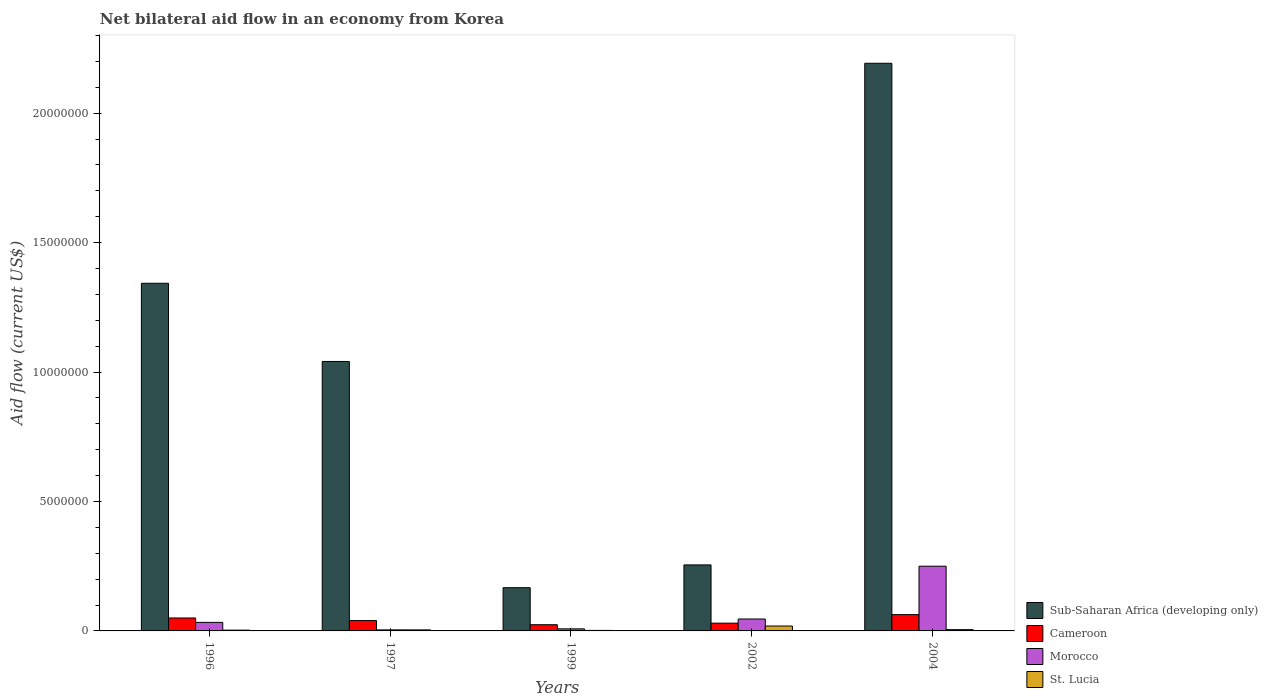How many different coloured bars are there?
Your answer should be compact. 4. How many groups of bars are there?
Provide a short and direct response. 5. Are the number of bars on each tick of the X-axis equal?
Provide a short and direct response. Yes. What is the net bilateral aid flow in Sub-Saharan Africa (developing only) in 1999?
Make the answer very short. 1.67e+06. Across all years, what is the maximum net bilateral aid flow in Cameroon?
Offer a terse response. 6.30e+05. Across all years, what is the minimum net bilateral aid flow in Sub-Saharan Africa (developing only)?
Make the answer very short. 1.67e+06. What is the total net bilateral aid flow in St. Lucia in the graph?
Your response must be concise. 3.30e+05. What is the difference between the net bilateral aid flow in Cameroon in 1999 and that in 2004?
Ensure brevity in your answer.  -3.90e+05. What is the difference between the net bilateral aid flow in St. Lucia in 1996 and the net bilateral aid flow in Cameroon in 2004?
Keep it short and to the point. -6.00e+05. What is the average net bilateral aid flow in Morocco per year?
Provide a succinct answer. 6.82e+05. In the year 1997, what is the difference between the net bilateral aid flow in Morocco and net bilateral aid flow in Sub-Saharan Africa (developing only)?
Give a very brief answer. -1.04e+07. In how many years, is the net bilateral aid flow in Sub-Saharan Africa (developing only) greater than 20000000 US$?
Provide a short and direct response. 1. What is the ratio of the net bilateral aid flow in Sub-Saharan Africa (developing only) in 2002 to that in 2004?
Make the answer very short. 0.12. Is the net bilateral aid flow in St. Lucia in 1999 less than that in 2004?
Provide a succinct answer. Yes. What is the difference between the highest and the second highest net bilateral aid flow in Morocco?
Your answer should be compact. 2.04e+06. What is the difference between the highest and the lowest net bilateral aid flow in Morocco?
Offer a terse response. 2.46e+06. Is the sum of the net bilateral aid flow in St. Lucia in 1997 and 1999 greater than the maximum net bilateral aid flow in Cameroon across all years?
Give a very brief answer. No. What does the 2nd bar from the left in 2002 represents?
Offer a terse response. Cameroon. What does the 2nd bar from the right in 1999 represents?
Provide a succinct answer. Morocco. Is it the case that in every year, the sum of the net bilateral aid flow in Morocco and net bilateral aid flow in Sub-Saharan Africa (developing only) is greater than the net bilateral aid flow in Cameroon?
Provide a succinct answer. Yes. How many bars are there?
Your answer should be very brief. 20. Are all the bars in the graph horizontal?
Offer a terse response. No. What is the difference between two consecutive major ticks on the Y-axis?
Offer a very short reply. 5.00e+06. Where does the legend appear in the graph?
Offer a terse response. Bottom right. How are the legend labels stacked?
Ensure brevity in your answer.  Vertical. What is the title of the graph?
Offer a very short reply. Net bilateral aid flow in an economy from Korea. What is the label or title of the Y-axis?
Provide a short and direct response. Aid flow (current US$). What is the Aid flow (current US$) in Sub-Saharan Africa (developing only) in 1996?
Offer a terse response. 1.34e+07. What is the Aid flow (current US$) of Cameroon in 1996?
Provide a short and direct response. 5.00e+05. What is the Aid flow (current US$) in Morocco in 1996?
Your answer should be very brief. 3.30e+05. What is the Aid flow (current US$) in Sub-Saharan Africa (developing only) in 1997?
Provide a short and direct response. 1.04e+07. What is the Aid flow (current US$) of Cameroon in 1997?
Your response must be concise. 4.00e+05. What is the Aid flow (current US$) in Morocco in 1997?
Provide a succinct answer. 4.00e+04. What is the Aid flow (current US$) in Sub-Saharan Africa (developing only) in 1999?
Offer a very short reply. 1.67e+06. What is the Aid flow (current US$) of Cameroon in 1999?
Your answer should be compact. 2.40e+05. What is the Aid flow (current US$) of Morocco in 1999?
Offer a terse response. 8.00e+04. What is the Aid flow (current US$) of Sub-Saharan Africa (developing only) in 2002?
Your answer should be compact. 2.55e+06. What is the Aid flow (current US$) in Cameroon in 2002?
Provide a short and direct response. 3.00e+05. What is the Aid flow (current US$) of Morocco in 2002?
Your response must be concise. 4.60e+05. What is the Aid flow (current US$) in Sub-Saharan Africa (developing only) in 2004?
Offer a terse response. 2.19e+07. What is the Aid flow (current US$) in Cameroon in 2004?
Your response must be concise. 6.30e+05. What is the Aid flow (current US$) of Morocco in 2004?
Keep it short and to the point. 2.50e+06. Across all years, what is the maximum Aid flow (current US$) of Sub-Saharan Africa (developing only)?
Give a very brief answer. 2.19e+07. Across all years, what is the maximum Aid flow (current US$) in Cameroon?
Your answer should be compact. 6.30e+05. Across all years, what is the maximum Aid flow (current US$) in Morocco?
Provide a short and direct response. 2.50e+06. Across all years, what is the maximum Aid flow (current US$) in St. Lucia?
Your response must be concise. 1.90e+05. Across all years, what is the minimum Aid flow (current US$) of Sub-Saharan Africa (developing only)?
Offer a very short reply. 1.67e+06. Across all years, what is the minimum Aid flow (current US$) of Cameroon?
Make the answer very short. 2.40e+05. What is the total Aid flow (current US$) of Sub-Saharan Africa (developing only) in the graph?
Give a very brief answer. 5.00e+07. What is the total Aid flow (current US$) in Cameroon in the graph?
Ensure brevity in your answer.  2.07e+06. What is the total Aid flow (current US$) of Morocco in the graph?
Offer a very short reply. 3.41e+06. What is the total Aid flow (current US$) in St. Lucia in the graph?
Offer a very short reply. 3.30e+05. What is the difference between the Aid flow (current US$) of Sub-Saharan Africa (developing only) in 1996 and that in 1997?
Provide a short and direct response. 3.02e+06. What is the difference between the Aid flow (current US$) in Sub-Saharan Africa (developing only) in 1996 and that in 1999?
Provide a short and direct response. 1.18e+07. What is the difference between the Aid flow (current US$) of Cameroon in 1996 and that in 1999?
Ensure brevity in your answer.  2.60e+05. What is the difference between the Aid flow (current US$) of Sub-Saharan Africa (developing only) in 1996 and that in 2002?
Keep it short and to the point. 1.09e+07. What is the difference between the Aid flow (current US$) in St. Lucia in 1996 and that in 2002?
Give a very brief answer. -1.60e+05. What is the difference between the Aid flow (current US$) in Sub-Saharan Africa (developing only) in 1996 and that in 2004?
Provide a succinct answer. -8.50e+06. What is the difference between the Aid flow (current US$) of Cameroon in 1996 and that in 2004?
Provide a succinct answer. -1.30e+05. What is the difference between the Aid flow (current US$) of Morocco in 1996 and that in 2004?
Provide a short and direct response. -2.17e+06. What is the difference between the Aid flow (current US$) of Sub-Saharan Africa (developing only) in 1997 and that in 1999?
Provide a succinct answer. 8.74e+06. What is the difference between the Aid flow (current US$) in Cameroon in 1997 and that in 1999?
Keep it short and to the point. 1.60e+05. What is the difference between the Aid flow (current US$) of St. Lucia in 1997 and that in 1999?
Provide a succinct answer. 2.00e+04. What is the difference between the Aid flow (current US$) of Sub-Saharan Africa (developing only) in 1997 and that in 2002?
Offer a very short reply. 7.86e+06. What is the difference between the Aid flow (current US$) in Cameroon in 1997 and that in 2002?
Offer a very short reply. 1.00e+05. What is the difference between the Aid flow (current US$) of Morocco in 1997 and that in 2002?
Give a very brief answer. -4.20e+05. What is the difference between the Aid flow (current US$) in St. Lucia in 1997 and that in 2002?
Provide a succinct answer. -1.50e+05. What is the difference between the Aid flow (current US$) of Sub-Saharan Africa (developing only) in 1997 and that in 2004?
Your answer should be compact. -1.15e+07. What is the difference between the Aid flow (current US$) in Morocco in 1997 and that in 2004?
Ensure brevity in your answer.  -2.46e+06. What is the difference between the Aid flow (current US$) of St. Lucia in 1997 and that in 2004?
Make the answer very short. -10000. What is the difference between the Aid flow (current US$) of Sub-Saharan Africa (developing only) in 1999 and that in 2002?
Your answer should be compact. -8.80e+05. What is the difference between the Aid flow (current US$) in Cameroon in 1999 and that in 2002?
Provide a short and direct response. -6.00e+04. What is the difference between the Aid flow (current US$) of Morocco in 1999 and that in 2002?
Offer a very short reply. -3.80e+05. What is the difference between the Aid flow (current US$) of Sub-Saharan Africa (developing only) in 1999 and that in 2004?
Your response must be concise. -2.03e+07. What is the difference between the Aid flow (current US$) of Cameroon in 1999 and that in 2004?
Provide a short and direct response. -3.90e+05. What is the difference between the Aid flow (current US$) of Morocco in 1999 and that in 2004?
Ensure brevity in your answer.  -2.42e+06. What is the difference between the Aid flow (current US$) in St. Lucia in 1999 and that in 2004?
Give a very brief answer. -3.00e+04. What is the difference between the Aid flow (current US$) in Sub-Saharan Africa (developing only) in 2002 and that in 2004?
Provide a succinct answer. -1.94e+07. What is the difference between the Aid flow (current US$) of Cameroon in 2002 and that in 2004?
Make the answer very short. -3.30e+05. What is the difference between the Aid flow (current US$) in Morocco in 2002 and that in 2004?
Keep it short and to the point. -2.04e+06. What is the difference between the Aid flow (current US$) in Sub-Saharan Africa (developing only) in 1996 and the Aid flow (current US$) in Cameroon in 1997?
Ensure brevity in your answer.  1.30e+07. What is the difference between the Aid flow (current US$) in Sub-Saharan Africa (developing only) in 1996 and the Aid flow (current US$) in Morocco in 1997?
Provide a succinct answer. 1.34e+07. What is the difference between the Aid flow (current US$) in Sub-Saharan Africa (developing only) in 1996 and the Aid flow (current US$) in St. Lucia in 1997?
Your answer should be very brief. 1.34e+07. What is the difference between the Aid flow (current US$) in Cameroon in 1996 and the Aid flow (current US$) in St. Lucia in 1997?
Give a very brief answer. 4.60e+05. What is the difference between the Aid flow (current US$) of Sub-Saharan Africa (developing only) in 1996 and the Aid flow (current US$) of Cameroon in 1999?
Your response must be concise. 1.32e+07. What is the difference between the Aid flow (current US$) in Sub-Saharan Africa (developing only) in 1996 and the Aid flow (current US$) in Morocco in 1999?
Provide a short and direct response. 1.34e+07. What is the difference between the Aid flow (current US$) of Sub-Saharan Africa (developing only) in 1996 and the Aid flow (current US$) of St. Lucia in 1999?
Provide a short and direct response. 1.34e+07. What is the difference between the Aid flow (current US$) of Sub-Saharan Africa (developing only) in 1996 and the Aid flow (current US$) of Cameroon in 2002?
Make the answer very short. 1.31e+07. What is the difference between the Aid flow (current US$) in Sub-Saharan Africa (developing only) in 1996 and the Aid flow (current US$) in Morocco in 2002?
Your answer should be compact. 1.30e+07. What is the difference between the Aid flow (current US$) of Sub-Saharan Africa (developing only) in 1996 and the Aid flow (current US$) of St. Lucia in 2002?
Provide a succinct answer. 1.32e+07. What is the difference between the Aid flow (current US$) in Cameroon in 1996 and the Aid flow (current US$) in Morocco in 2002?
Provide a short and direct response. 4.00e+04. What is the difference between the Aid flow (current US$) in Cameroon in 1996 and the Aid flow (current US$) in St. Lucia in 2002?
Offer a very short reply. 3.10e+05. What is the difference between the Aid flow (current US$) in Sub-Saharan Africa (developing only) in 1996 and the Aid flow (current US$) in Cameroon in 2004?
Provide a succinct answer. 1.28e+07. What is the difference between the Aid flow (current US$) in Sub-Saharan Africa (developing only) in 1996 and the Aid flow (current US$) in Morocco in 2004?
Offer a very short reply. 1.09e+07. What is the difference between the Aid flow (current US$) of Sub-Saharan Africa (developing only) in 1996 and the Aid flow (current US$) of St. Lucia in 2004?
Make the answer very short. 1.34e+07. What is the difference between the Aid flow (current US$) in Cameroon in 1996 and the Aid flow (current US$) in Morocco in 2004?
Your response must be concise. -2.00e+06. What is the difference between the Aid flow (current US$) in Cameroon in 1996 and the Aid flow (current US$) in St. Lucia in 2004?
Offer a very short reply. 4.50e+05. What is the difference between the Aid flow (current US$) in Sub-Saharan Africa (developing only) in 1997 and the Aid flow (current US$) in Cameroon in 1999?
Ensure brevity in your answer.  1.02e+07. What is the difference between the Aid flow (current US$) in Sub-Saharan Africa (developing only) in 1997 and the Aid flow (current US$) in Morocco in 1999?
Ensure brevity in your answer.  1.03e+07. What is the difference between the Aid flow (current US$) of Sub-Saharan Africa (developing only) in 1997 and the Aid flow (current US$) of St. Lucia in 1999?
Keep it short and to the point. 1.04e+07. What is the difference between the Aid flow (current US$) of Cameroon in 1997 and the Aid flow (current US$) of Morocco in 1999?
Offer a very short reply. 3.20e+05. What is the difference between the Aid flow (current US$) in Sub-Saharan Africa (developing only) in 1997 and the Aid flow (current US$) in Cameroon in 2002?
Give a very brief answer. 1.01e+07. What is the difference between the Aid flow (current US$) of Sub-Saharan Africa (developing only) in 1997 and the Aid flow (current US$) of Morocco in 2002?
Provide a succinct answer. 9.95e+06. What is the difference between the Aid flow (current US$) in Sub-Saharan Africa (developing only) in 1997 and the Aid flow (current US$) in St. Lucia in 2002?
Offer a very short reply. 1.02e+07. What is the difference between the Aid flow (current US$) in Morocco in 1997 and the Aid flow (current US$) in St. Lucia in 2002?
Ensure brevity in your answer.  -1.50e+05. What is the difference between the Aid flow (current US$) in Sub-Saharan Africa (developing only) in 1997 and the Aid flow (current US$) in Cameroon in 2004?
Your response must be concise. 9.78e+06. What is the difference between the Aid flow (current US$) in Sub-Saharan Africa (developing only) in 1997 and the Aid flow (current US$) in Morocco in 2004?
Your answer should be very brief. 7.91e+06. What is the difference between the Aid flow (current US$) in Sub-Saharan Africa (developing only) in 1997 and the Aid flow (current US$) in St. Lucia in 2004?
Offer a terse response. 1.04e+07. What is the difference between the Aid flow (current US$) in Cameroon in 1997 and the Aid flow (current US$) in Morocco in 2004?
Your answer should be very brief. -2.10e+06. What is the difference between the Aid flow (current US$) in Cameroon in 1997 and the Aid flow (current US$) in St. Lucia in 2004?
Provide a succinct answer. 3.50e+05. What is the difference between the Aid flow (current US$) of Morocco in 1997 and the Aid flow (current US$) of St. Lucia in 2004?
Provide a short and direct response. -10000. What is the difference between the Aid flow (current US$) of Sub-Saharan Africa (developing only) in 1999 and the Aid flow (current US$) of Cameroon in 2002?
Your answer should be very brief. 1.37e+06. What is the difference between the Aid flow (current US$) of Sub-Saharan Africa (developing only) in 1999 and the Aid flow (current US$) of Morocco in 2002?
Give a very brief answer. 1.21e+06. What is the difference between the Aid flow (current US$) of Sub-Saharan Africa (developing only) in 1999 and the Aid flow (current US$) of St. Lucia in 2002?
Give a very brief answer. 1.48e+06. What is the difference between the Aid flow (current US$) of Morocco in 1999 and the Aid flow (current US$) of St. Lucia in 2002?
Your answer should be very brief. -1.10e+05. What is the difference between the Aid flow (current US$) in Sub-Saharan Africa (developing only) in 1999 and the Aid flow (current US$) in Cameroon in 2004?
Make the answer very short. 1.04e+06. What is the difference between the Aid flow (current US$) in Sub-Saharan Africa (developing only) in 1999 and the Aid flow (current US$) in Morocco in 2004?
Provide a succinct answer. -8.30e+05. What is the difference between the Aid flow (current US$) of Sub-Saharan Africa (developing only) in 1999 and the Aid flow (current US$) of St. Lucia in 2004?
Your response must be concise. 1.62e+06. What is the difference between the Aid flow (current US$) in Cameroon in 1999 and the Aid flow (current US$) in Morocco in 2004?
Offer a terse response. -2.26e+06. What is the difference between the Aid flow (current US$) of Cameroon in 1999 and the Aid flow (current US$) of St. Lucia in 2004?
Keep it short and to the point. 1.90e+05. What is the difference between the Aid flow (current US$) of Sub-Saharan Africa (developing only) in 2002 and the Aid flow (current US$) of Cameroon in 2004?
Your answer should be compact. 1.92e+06. What is the difference between the Aid flow (current US$) of Sub-Saharan Africa (developing only) in 2002 and the Aid flow (current US$) of St. Lucia in 2004?
Make the answer very short. 2.50e+06. What is the difference between the Aid flow (current US$) in Cameroon in 2002 and the Aid flow (current US$) in Morocco in 2004?
Your response must be concise. -2.20e+06. What is the difference between the Aid flow (current US$) in Morocco in 2002 and the Aid flow (current US$) in St. Lucia in 2004?
Provide a short and direct response. 4.10e+05. What is the average Aid flow (current US$) of Sub-Saharan Africa (developing only) per year?
Provide a succinct answer. 1.00e+07. What is the average Aid flow (current US$) in Cameroon per year?
Offer a terse response. 4.14e+05. What is the average Aid flow (current US$) in Morocco per year?
Make the answer very short. 6.82e+05. What is the average Aid flow (current US$) in St. Lucia per year?
Your response must be concise. 6.60e+04. In the year 1996, what is the difference between the Aid flow (current US$) in Sub-Saharan Africa (developing only) and Aid flow (current US$) in Cameroon?
Your answer should be compact. 1.29e+07. In the year 1996, what is the difference between the Aid flow (current US$) in Sub-Saharan Africa (developing only) and Aid flow (current US$) in Morocco?
Give a very brief answer. 1.31e+07. In the year 1996, what is the difference between the Aid flow (current US$) of Sub-Saharan Africa (developing only) and Aid flow (current US$) of St. Lucia?
Provide a short and direct response. 1.34e+07. In the year 1996, what is the difference between the Aid flow (current US$) in Cameroon and Aid flow (current US$) in St. Lucia?
Your response must be concise. 4.70e+05. In the year 1996, what is the difference between the Aid flow (current US$) in Morocco and Aid flow (current US$) in St. Lucia?
Your answer should be compact. 3.00e+05. In the year 1997, what is the difference between the Aid flow (current US$) in Sub-Saharan Africa (developing only) and Aid flow (current US$) in Cameroon?
Offer a very short reply. 1.00e+07. In the year 1997, what is the difference between the Aid flow (current US$) in Sub-Saharan Africa (developing only) and Aid flow (current US$) in Morocco?
Keep it short and to the point. 1.04e+07. In the year 1997, what is the difference between the Aid flow (current US$) of Sub-Saharan Africa (developing only) and Aid flow (current US$) of St. Lucia?
Make the answer very short. 1.04e+07. In the year 1997, what is the difference between the Aid flow (current US$) of Cameroon and Aid flow (current US$) of Morocco?
Keep it short and to the point. 3.60e+05. In the year 1997, what is the difference between the Aid flow (current US$) of Morocco and Aid flow (current US$) of St. Lucia?
Your response must be concise. 0. In the year 1999, what is the difference between the Aid flow (current US$) of Sub-Saharan Africa (developing only) and Aid flow (current US$) of Cameroon?
Give a very brief answer. 1.43e+06. In the year 1999, what is the difference between the Aid flow (current US$) of Sub-Saharan Africa (developing only) and Aid flow (current US$) of Morocco?
Make the answer very short. 1.59e+06. In the year 1999, what is the difference between the Aid flow (current US$) in Sub-Saharan Africa (developing only) and Aid flow (current US$) in St. Lucia?
Keep it short and to the point. 1.65e+06. In the year 1999, what is the difference between the Aid flow (current US$) of Cameroon and Aid flow (current US$) of St. Lucia?
Offer a terse response. 2.20e+05. In the year 1999, what is the difference between the Aid flow (current US$) in Morocco and Aid flow (current US$) in St. Lucia?
Ensure brevity in your answer.  6.00e+04. In the year 2002, what is the difference between the Aid flow (current US$) of Sub-Saharan Africa (developing only) and Aid flow (current US$) of Cameroon?
Provide a short and direct response. 2.25e+06. In the year 2002, what is the difference between the Aid flow (current US$) in Sub-Saharan Africa (developing only) and Aid flow (current US$) in Morocco?
Give a very brief answer. 2.09e+06. In the year 2002, what is the difference between the Aid flow (current US$) of Sub-Saharan Africa (developing only) and Aid flow (current US$) of St. Lucia?
Your response must be concise. 2.36e+06. In the year 2002, what is the difference between the Aid flow (current US$) in Cameroon and Aid flow (current US$) in Morocco?
Your answer should be compact. -1.60e+05. In the year 2004, what is the difference between the Aid flow (current US$) of Sub-Saharan Africa (developing only) and Aid flow (current US$) of Cameroon?
Give a very brief answer. 2.13e+07. In the year 2004, what is the difference between the Aid flow (current US$) in Sub-Saharan Africa (developing only) and Aid flow (current US$) in Morocco?
Offer a very short reply. 1.94e+07. In the year 2004, what is the difference between the Aid flow (current US$) of Sub-Saharan Africa (developing only) and Aid flow (current US$) of St. Lucia?
Your answer should be very brief. 2.19e+07. In the year 2004, what is the difference between the Aid flow (current US$) in Cameroon and Aid flow (current US$) in Morocco?
Your response must be concise. -1.87e+06. In the year 2004, what is the difference between the Aid flow (current US$) of Cameroon and Aid flow (current US$) of St. Lucia?
Provide a short and direct response. 5.80e+05. In the year 2004, what is the difference between the Aid flow (current US$) in Morocco and Aid flow (current US$) in St. Lucia?
Provide a succinct answer. 2.45e+06. What is the ratio of the Aid flow (current US$) of Sub-Saharan Africa (developing only) in 1996 to that in 1997?
Keep it short and to the point. 1.29. What is the ratio of the Aid flow (current US$) of Cameroon in 1996 to that in 1997?
Provide a short and direct response. 1.25. What is the ratio of the Aid flow (current US$) of Morocco in 1996 to that in 1997?
Your response must be concise. 8.25. What is the ratio of the Aid flow (current US$) in Sub-Saharan Africa (developing only) in 1996 to that in 1999?
Your answer should be very brief. 8.04. What is the ratio of the Aid flow (current US$) of Cameroon in 1996 to that in 1999?
Give a very brief answer. 2.08. What is the ratio of the Aid flow (current US$) in Morocco in 1996 to that in 1999?
Provide a short and direct response. 4.12. What is the ratio of the Aid flow (current US$) in St. Lucia in 1996 to that in 1999?
Your response must be concise. 1.5. What is the ratio of the Aid flow (current US$) in Sub-Saharan Africa (developing only) in 1996 to that in 2002?
Provide a succinct answer. 5.27. What is the ratio of the Aid flow (current US$) of Morocco in 1996 to that in 2002?
Keep it short and to the point. 0.72. What is the ratio of the Aid flow (current US$) in St. Lucia in 1996 to that in 2002?
Ensure brevity in your answer.  0.16. What is the ratio of the Aid flow (current US$) of Sub-Saharan Africa (developing only) in 1996 to that in 2004?
Your response must be concise. 0.61. What is the ratio of the Aid flow (current US$) in Cameroon in 1996 to that in 2004?
Give a very brief answer. 0.79. What is the ratio of the Aid flow (current US$) in Morocco in 1996 to that in 2004?
Your response must be concise. 0.13. What is the ratio of the Aid flow (current US$) of Sub-Saharan Africa (developing only) in 1997 to that in 1999?
Make the answer very short. 6.23. What is the ratio of the Aid flow (current US$) of Cameroon in 1997 to that in 1999?
Make the answer very short. 1.67. What is the ratio of the Aid flow (current US$) of St. Lucia in 1997 to that in 1999?
Offer a very short reply. 2. What is the ratio of the Aid flow (current US$) in Sub-Saharan Africa (developing only) in 1997 to that in 2002?
Your answer should be compact. 4.08. What is the ratio of the Aid flow (current US$) in Morocco in 1997 to that in 2002?
Provide a succinct answer. 0.09. What is the ratio of the Aid flow (current US$) of St. Lucia in 1997 to that in 2002?
Your answer should be compact. 0.21. What is the ratio of the Aid flow (current US$) of Sub-Saharan Africa (developing only) in 1997 to that in 2004?
Give a very brief answer. 0.47. What is the ratio of the Aid flow (current US$) of Cameroon in 1997 to that in 2004?
Keep it short and to the point. 0.63. What is the ratio of the Aid flow (current US$) in Morocco in 1997 to that in 2004?
Your answer should be compact. 0.02. What is the ratio of the Aid flow (current US$) in Sub-Saharan Africa (developing only) in 1999 to that in 2002?
Make the answer very short. 0.65. What is the ratio of the Aid flow (current US$) in Cameroon in 1999 to that in 2002?
Your answer should be very brief. 0.8. What is the ratio of the Aid flow (current US$) of Morocco in 1999 to that in 2002?
Offer a very short reply. 0.17. What is the ratio of the Aid flow (current US$) in St. Lucia in 1999 to that in 2002?
Ensure brevity in your answer.  0.11. What is the ratio of the Aid flow (current US$) of Sub-Saharan Africa (developing only) in 1999 to that in 2004?
Keep it short and to the point. 0.08. What is the ratio of the Aid flow (current US$) in Cameroon in 1999 to that in 2004?
Ensure brevity in your answer.  0.38. What is the ratio of the Aid flow (current US$) in Morocco in 1999 to that in 2004?
Your answer should be very brief. 0.03. What is the ratio of the Aid flow (current US$) of St. Lucia in 1999 to that in 2004?
Provide a short and direct response. 0.4. What is the ratio of the Aid flow (current US$) of Sub-Saharan Africa (developing only) in 2002 to that in 2004?
Give a very brief answer. 0.12. What is the ratio of the Aid flow (current US$) in Cameroon in 2002 to that in 2004?
Give a very brief answer. 0.48. What is the ratio of the Aid flow (current US$) of Morocco in 2002 to that in 2004?
Your answer should be compact. 0.18. What is the ratio of the Aid flow (current US$) of St. Lucia in 2002 to that in 2004?
Offer a terse response. 3.8. What is the difference between the highest and the second highest Aid flow (current US$) of Sub-Saharan Africa (developing only)?
Give a very brief answer. 8.50e+06. What is the difference between the highest and the second highest Aid flow (current US$) of Cameroon?
Ensure brevity in your answer.  1.30e+05. What is the difference between the highest and the second highest Aid flow (current US$) in Morocco?
Provide a succinct answer. 2.04e+06. What is the difference between the highest and the second highest Aid flow (current US$) in St. Lucia?
Provide a succinct answer. 1.40e+05. What is the difference between the highest and the lowest Aid flow (current US$) of Sub-Saharan Africa (developing only)?
Provide a succinct answer. 2.03e+07. What is the difference between the highest and the lowest Aid flow (current US$) in Cameroon?
Provide a short and direct response. 3.90e+05. What is the difference between the highest and the lowest Aid flow (current US$) of Morocco?
Provide a short and direct response. 2.46e+06. What is the difference between the highest and the lowest Aid flow (current US$) of St. Lucia?
Give a very brief answer. 1.70e+05. 